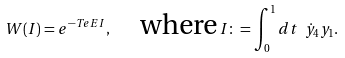<formula> <loc_0><loc_0><loc_500><loc_500>W ( I ) = e ^ { - T e E I } , \quad \text {where} \, I \colon = \int _ { 0 } ^ { 1 } d t \ \dot { y } _ { 4 } y _ { 1 } .</formula> 